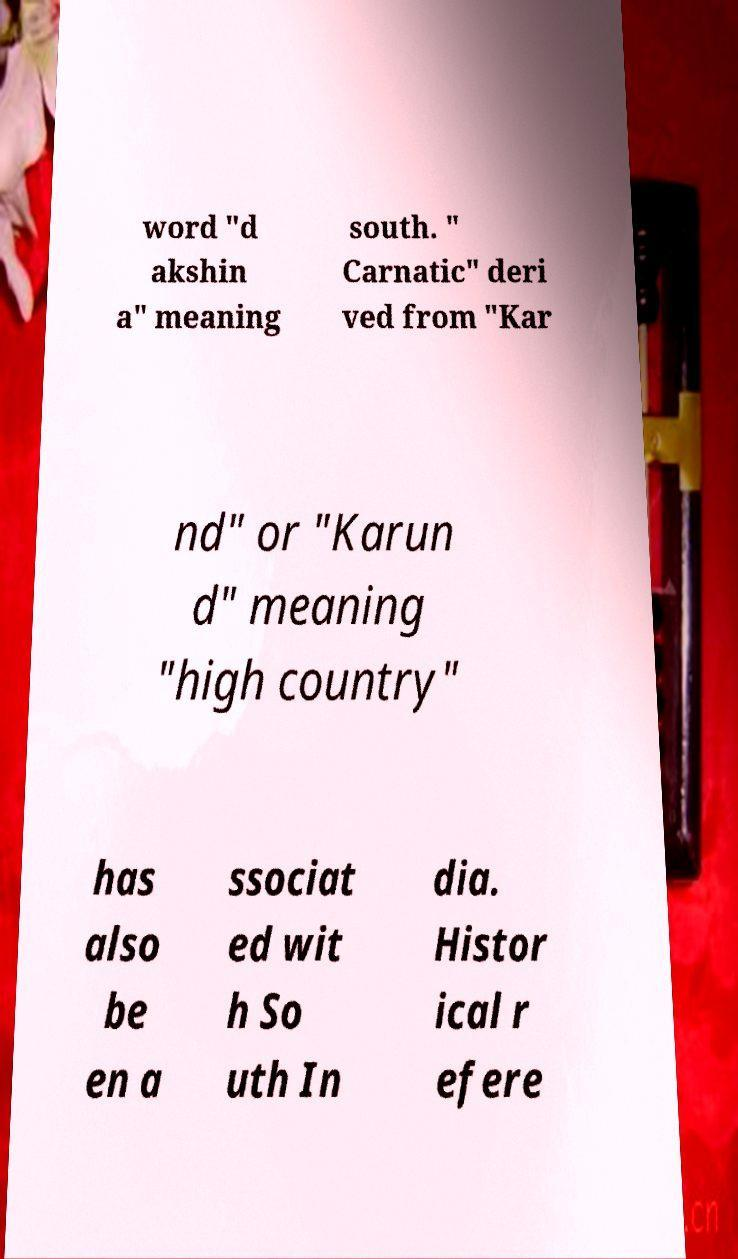There's text embedded in this image that I need extracted. Can you transcribe it verbatim? word "d akshin a" meaning south. " Carnatic" deri ved from "Kar nd" or "Karun d" meaning "high country" has also be en a ssociat ed wit h So uth In dia. Histor ical r efere 